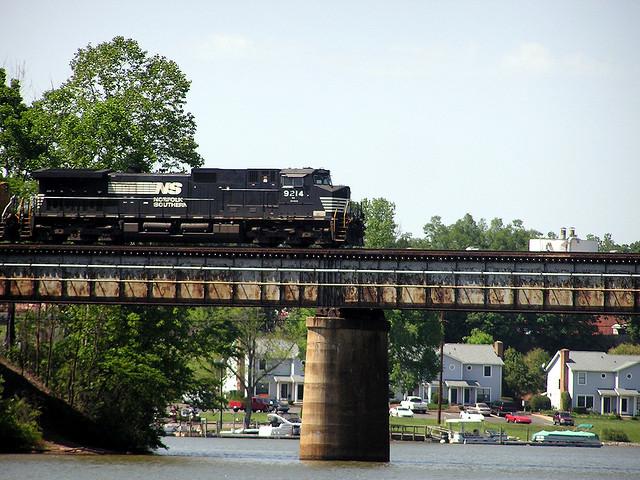Is the train in motion?
Short answer required. Yes. What letters are visible on the train?
Keep it brief. Ns. What does the bridge go over?
Short answer required. Water. 